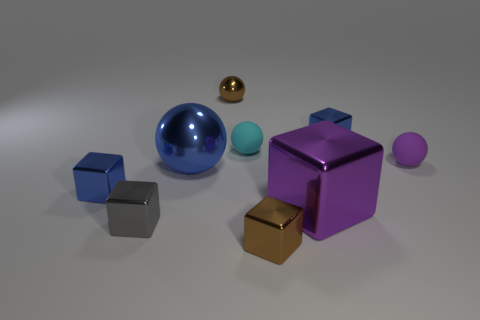Subtract all spheres. How many objects are left? 5 Subtract all tiny spheres. Subtract all blue shiny things. How many objects are left? 3 Add 5 purple objects. How many purple objects are left? 7 Add 3 small things. How many small things exist? 10 Subtract all brown cubes. How many cubes are left? 4 Subtract all blue metal blocks. How many blocks are left? 3 Subtract 0 green cylinders. How many objects are left? 9 Subtract 1 cubes. How many cubes are left? 4 Subtract all green spheres. Subtract all blue blocks. How many spheres are left? 4 Subtract all blue cubes. How many green spheres are left? 0 